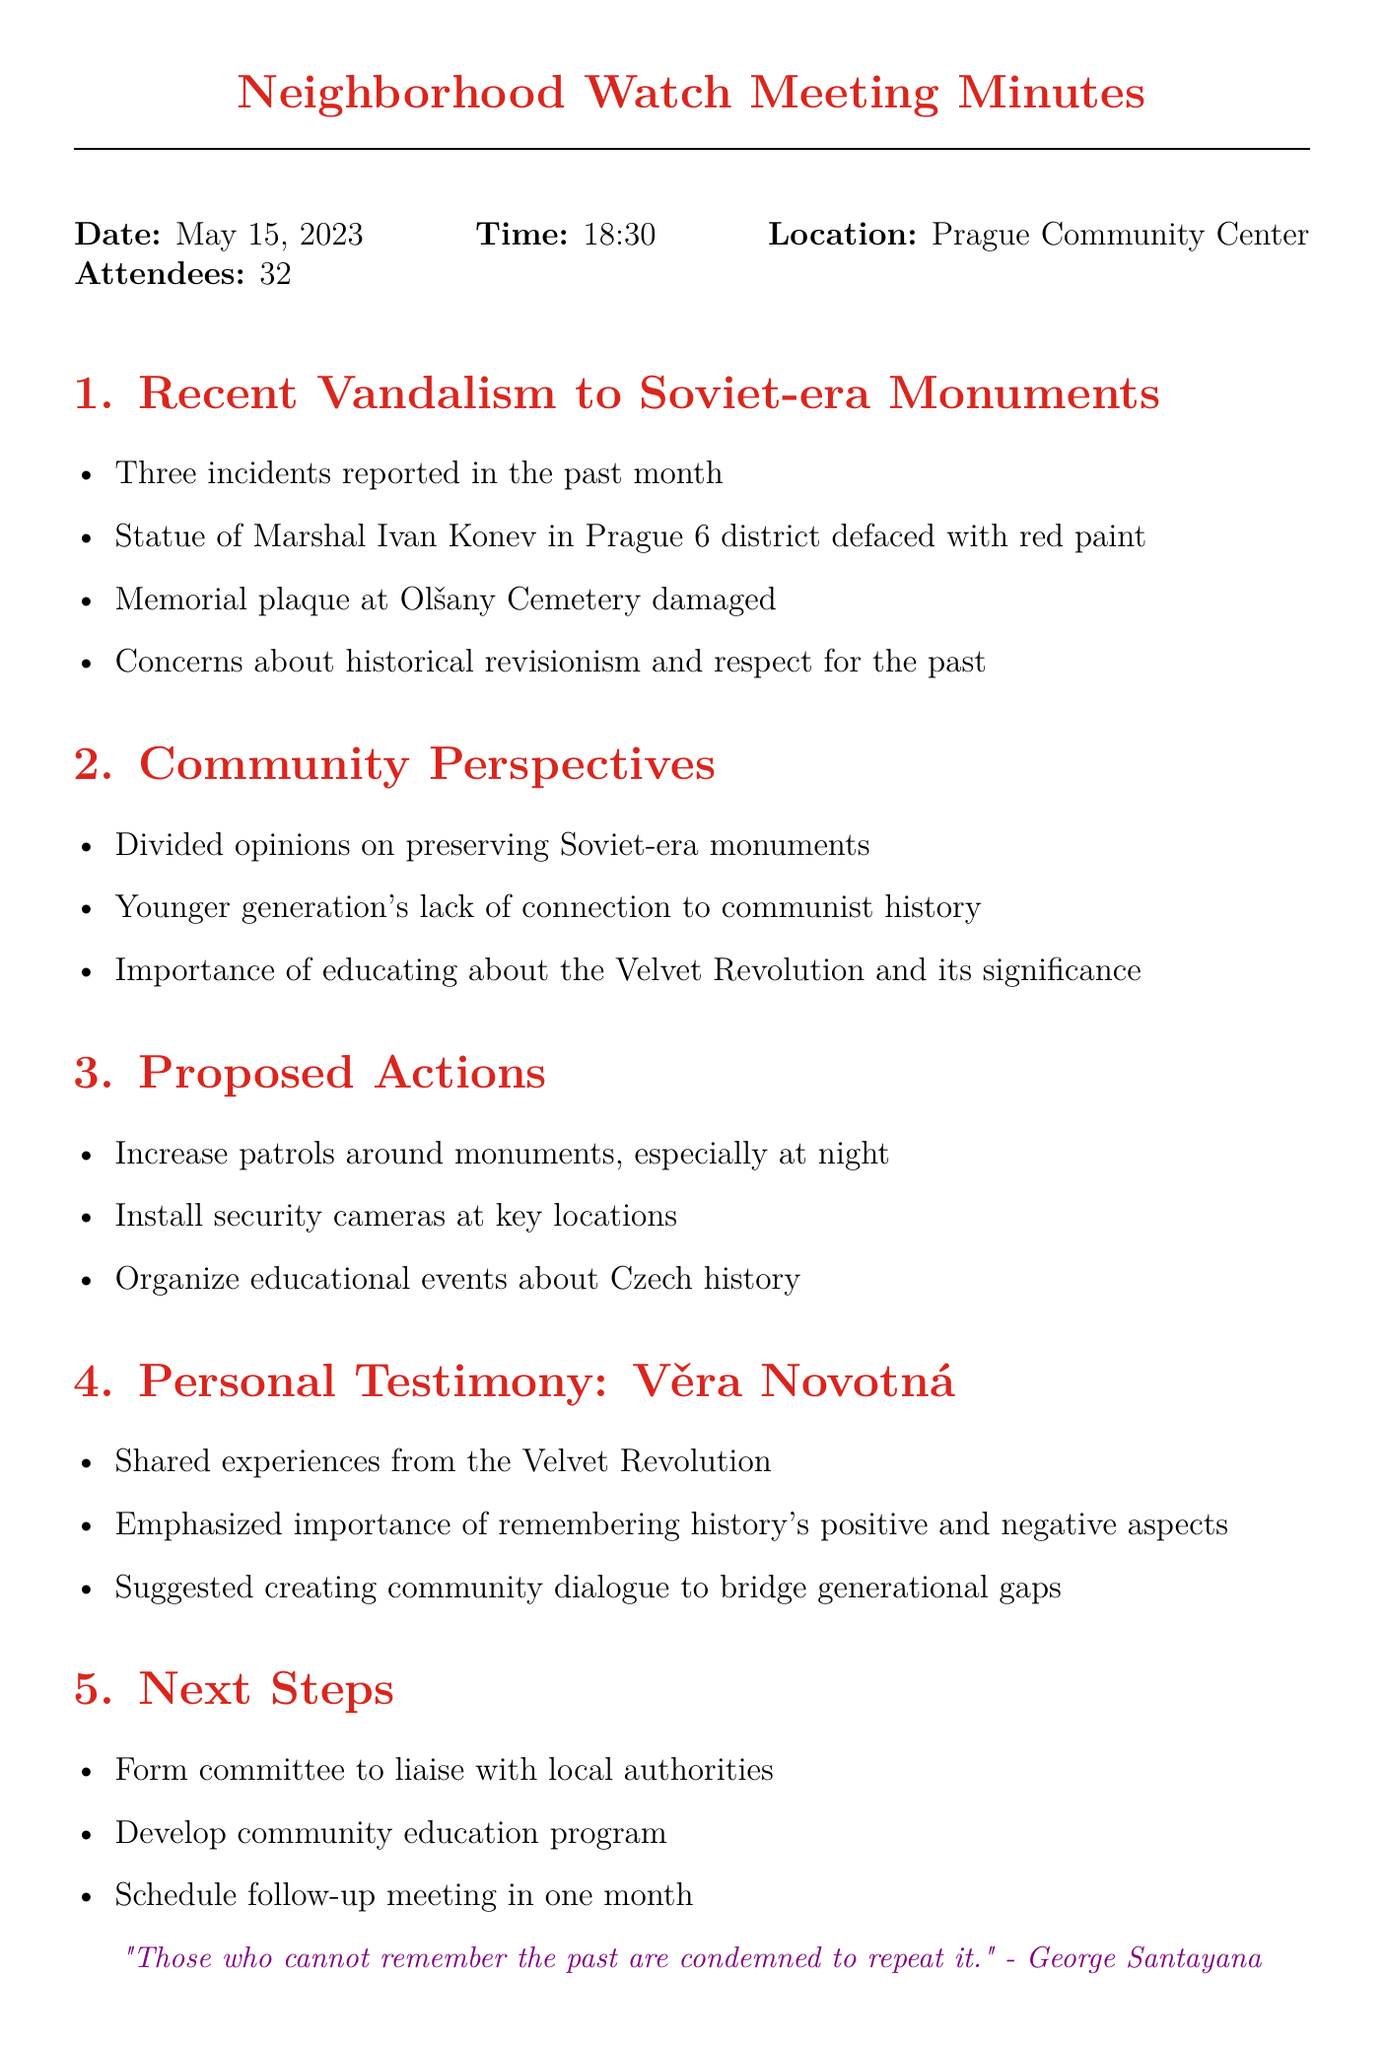What date did the neighborhood watch meeting occur? The date of the meeting is stated clearly in the document as May 15, 2023.
Answer: May 15, 2023 How many attendees were present at the meeting? The number of attendees is mentioned in the document right after the date and time.
Answer: 32 What specific statue was defaced in Prague? The document lists the statue that was defaced, which is the Statue of Marshal Ivan Konev.
Answer: Statue of Marshal Ivan Konev What was suggested to increase security around the monuments? The proposed actions included increasing patrols around the monuments.
Answer: Increase patrols Who shared personal testimony about the Velvet Revolution? The document specifies that the personal testimony was shared by Věra Novotná.
Answer: Věra Novotná What was one concern raised about historical monuments? The minutes mention concerns regarding historical revisionism.
Answer: Historical revisionism What educational event was proposed in the meeting? The proposed actions included organizing educational events about Czech history.
Answer: Educational events about Czech history What will the community do one month after the meeting? The next steps outline scheduling a follow-up meeting in one month to review progress.
Answer: Schedule follow-up meeting 